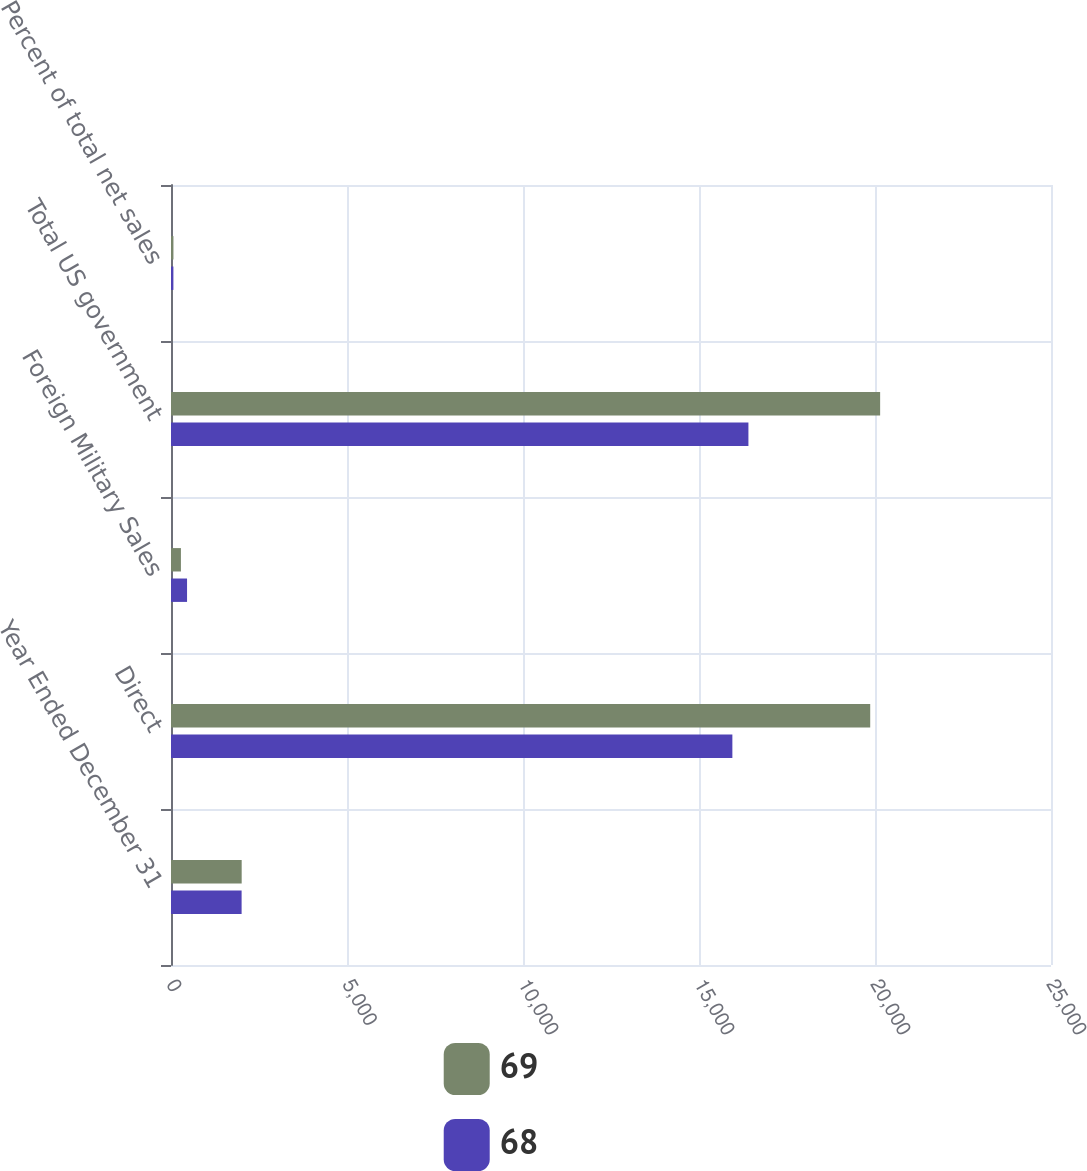Convert chart. <chart><loc_0><loc_0><loc_500><loc_500><stacked_bar_chart><ecel><fcel>Year Ended December 31<fcel>Direct<fcel>Foreign Military Sales<fcel>Total US government<fcel>Percent of total net sales<nl><fcel>69<fcel>2008<fcel>19864<fcel>282<fcel>20146<fcel>69<nl><fcel>68<fcel>2006<fcel>15948<fcel>456<fcel>16404<fcel>68<nl></chart> 